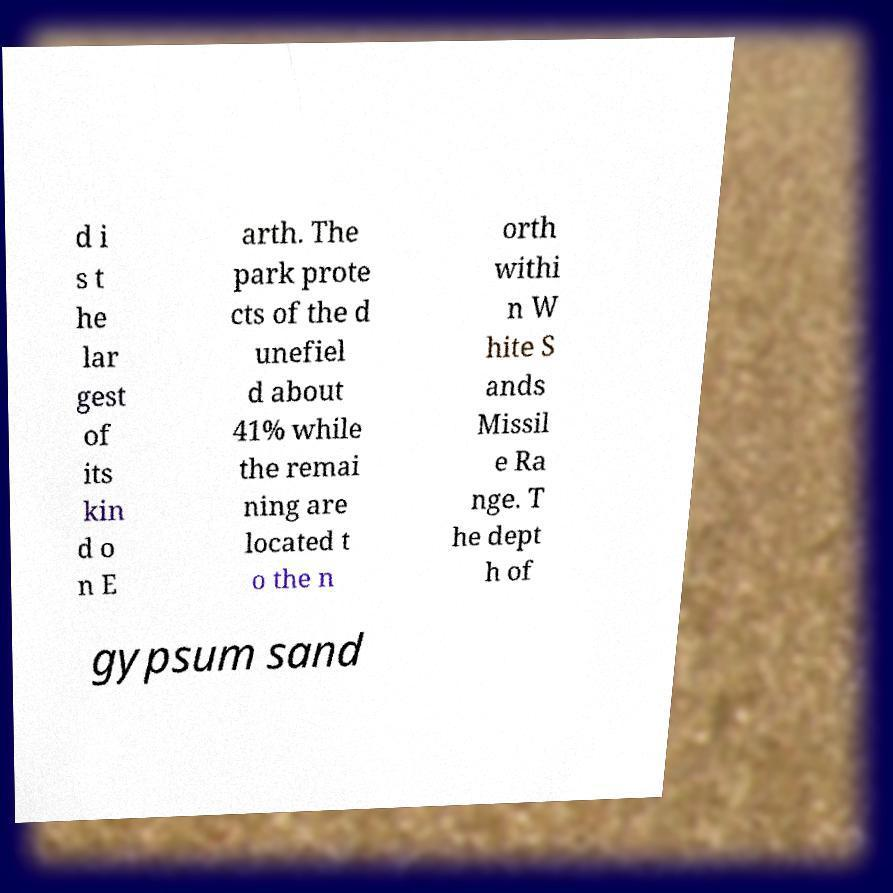What messages or text are displayed in this image? I need them in a readable, typed format. d i s t he lar gest of its kin d o n E arth. The park prote cts of the d unefiel d about 41% while the remai ning are located t o the n orth withi n W hite S ands Missil e Ra nge. T he dept h of gypsum sand 